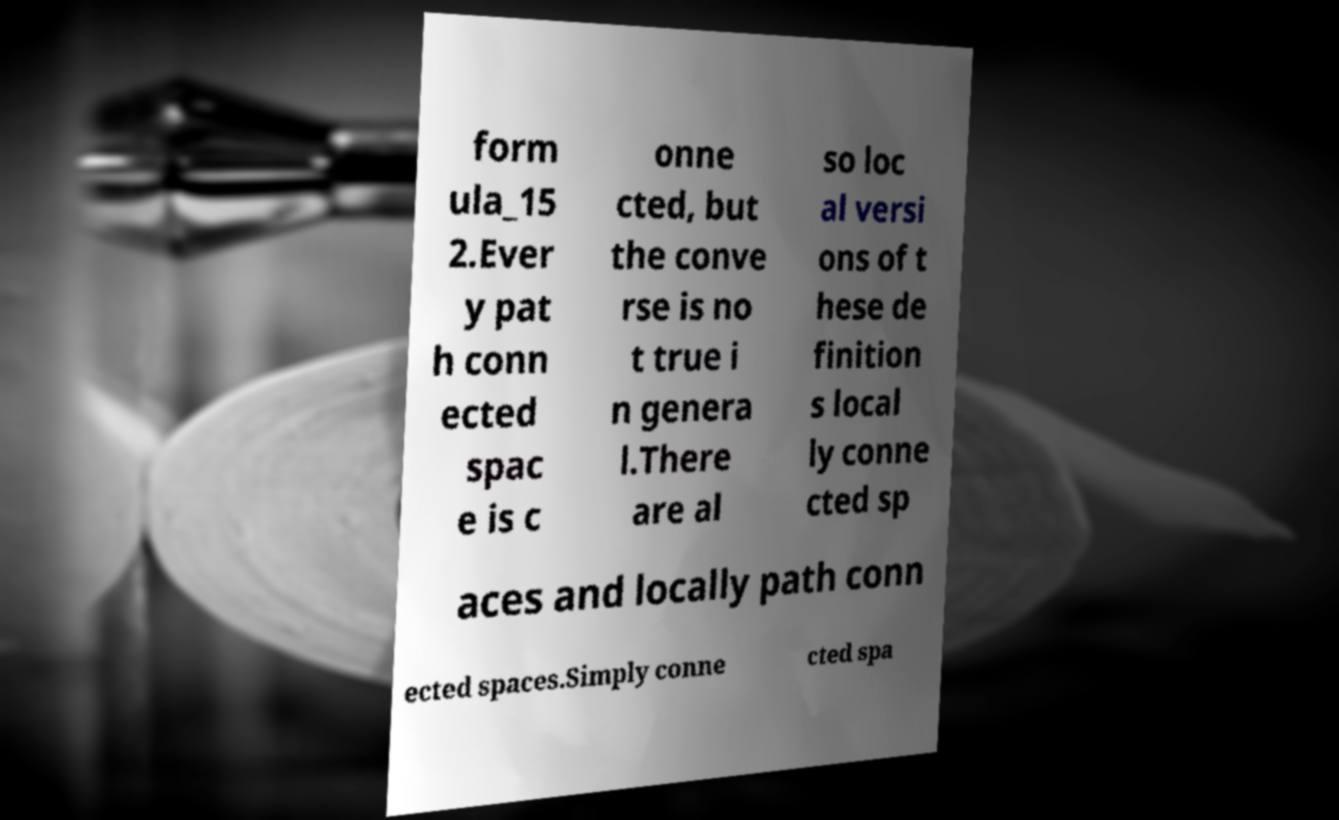What messages or text are displayed in this image? I need them in a readable, typed format. form ula_15 2.Ever y pat h conn ected spac e is c onne cted, but the conve rse is no t true i n genera l.There are al so loc al versi ons of t hese de finition s local ly conne cted sp aces and locally path conn ected spaces.Simply conne cted spa 